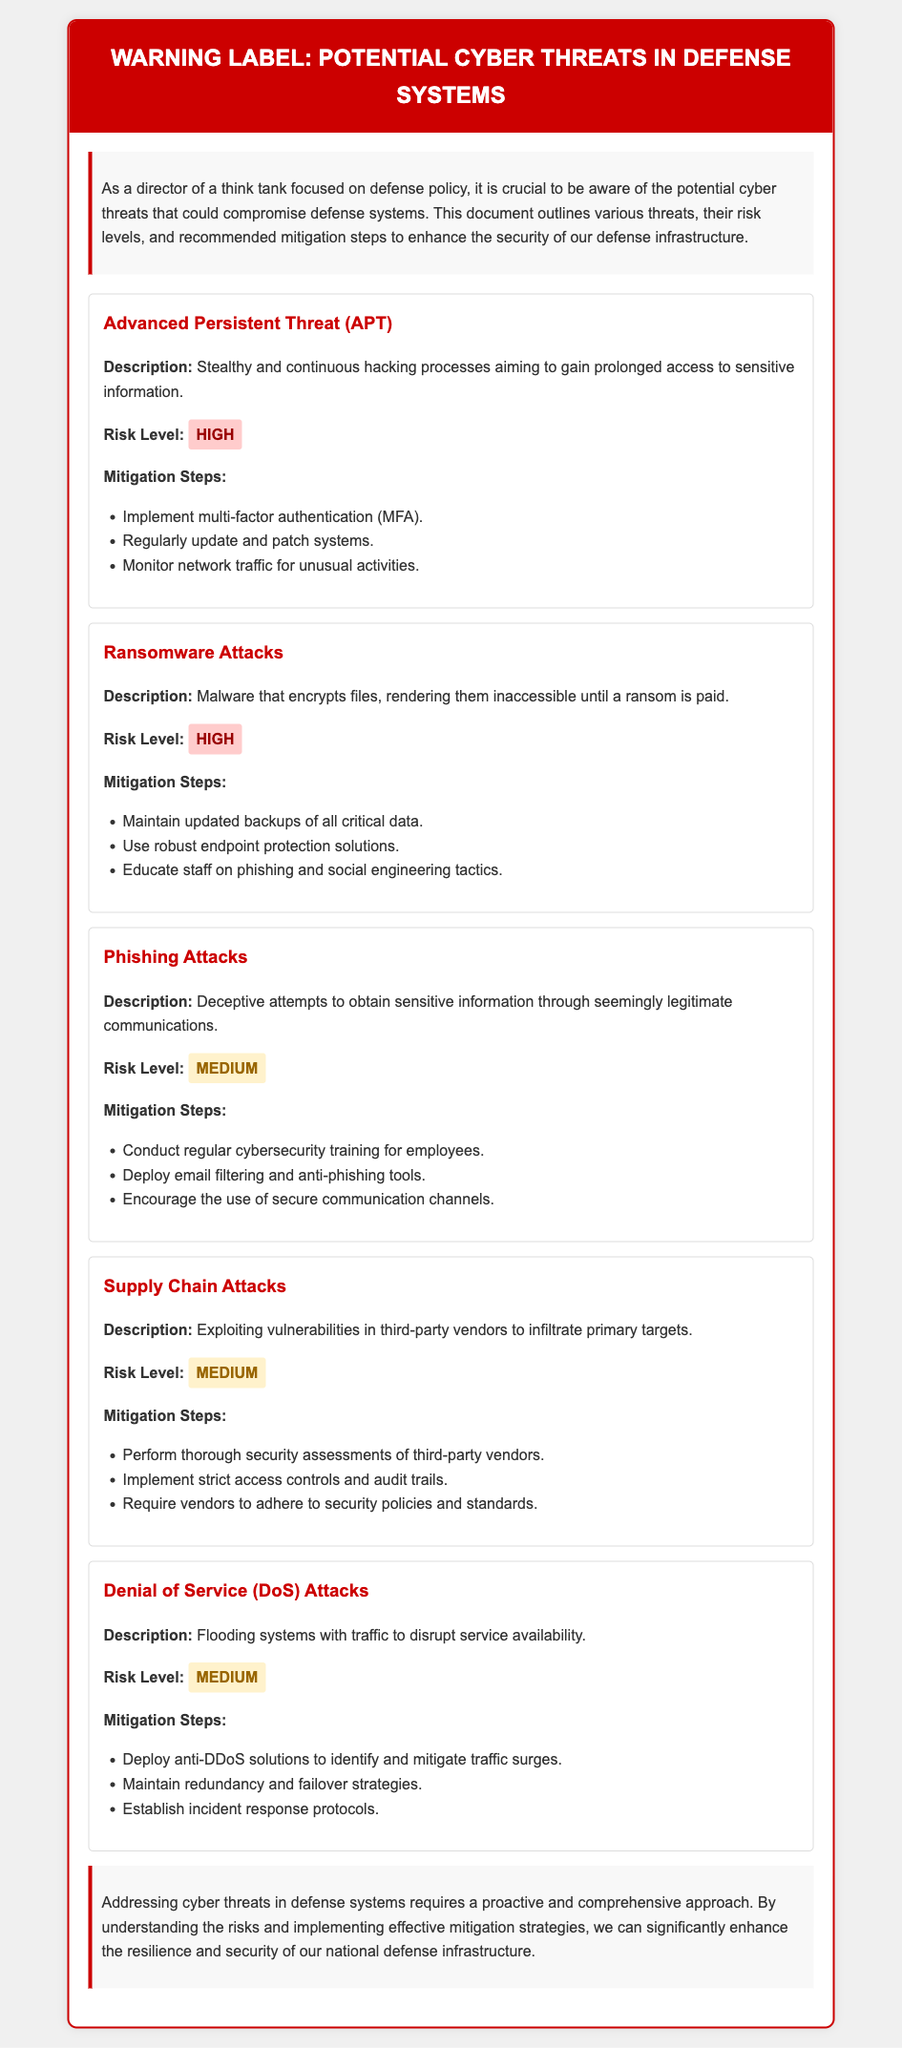What is an Advanced Persistent Threat? An Advanced Persistent Threat is a stealthy and continuous hacking process aiming to gain prolonged access to sensitive information.
Answer: Stealthy and continuous hacking What is the risk level of Ransomware Attacks? The risk level of Ransomware Attacks is classified in the document under its risk assessment.
Answer: High List one mitigation step for Phishing Attacks. The document outlines various mitigation steps for each threat; one of them is to conduct regular cybersecurity training for employees.
Answer: Conduct regular cybersecurity training What threat involves exploiting vulnerabilities in third-party vendors? The document specifies a type of threat that targets third-party vendors to infiltrate primary targets.
Answer: Supply Chain Attacks How many types of mitigation steps are listed for Denial of Service attacks? By analyzing the listed mitigation steps provided in the document, we can count their quantity related to this threat.
Answer: Three What color indicates a High risk level in the document? The document uses specific colors as indicators for risk levels, including one that signifies high risk.
Answer: Red Which threat has a Medium risk level? The document lists multiple threats and categorizes their risk levels; identifying one categorized as medium is essential.
Answer: Phishing Attacks What does MFA stand for in mitigation strategies? The term is introduced in connection with mitigation steps for cyber threats.
Answer: Multi-factor authentication 